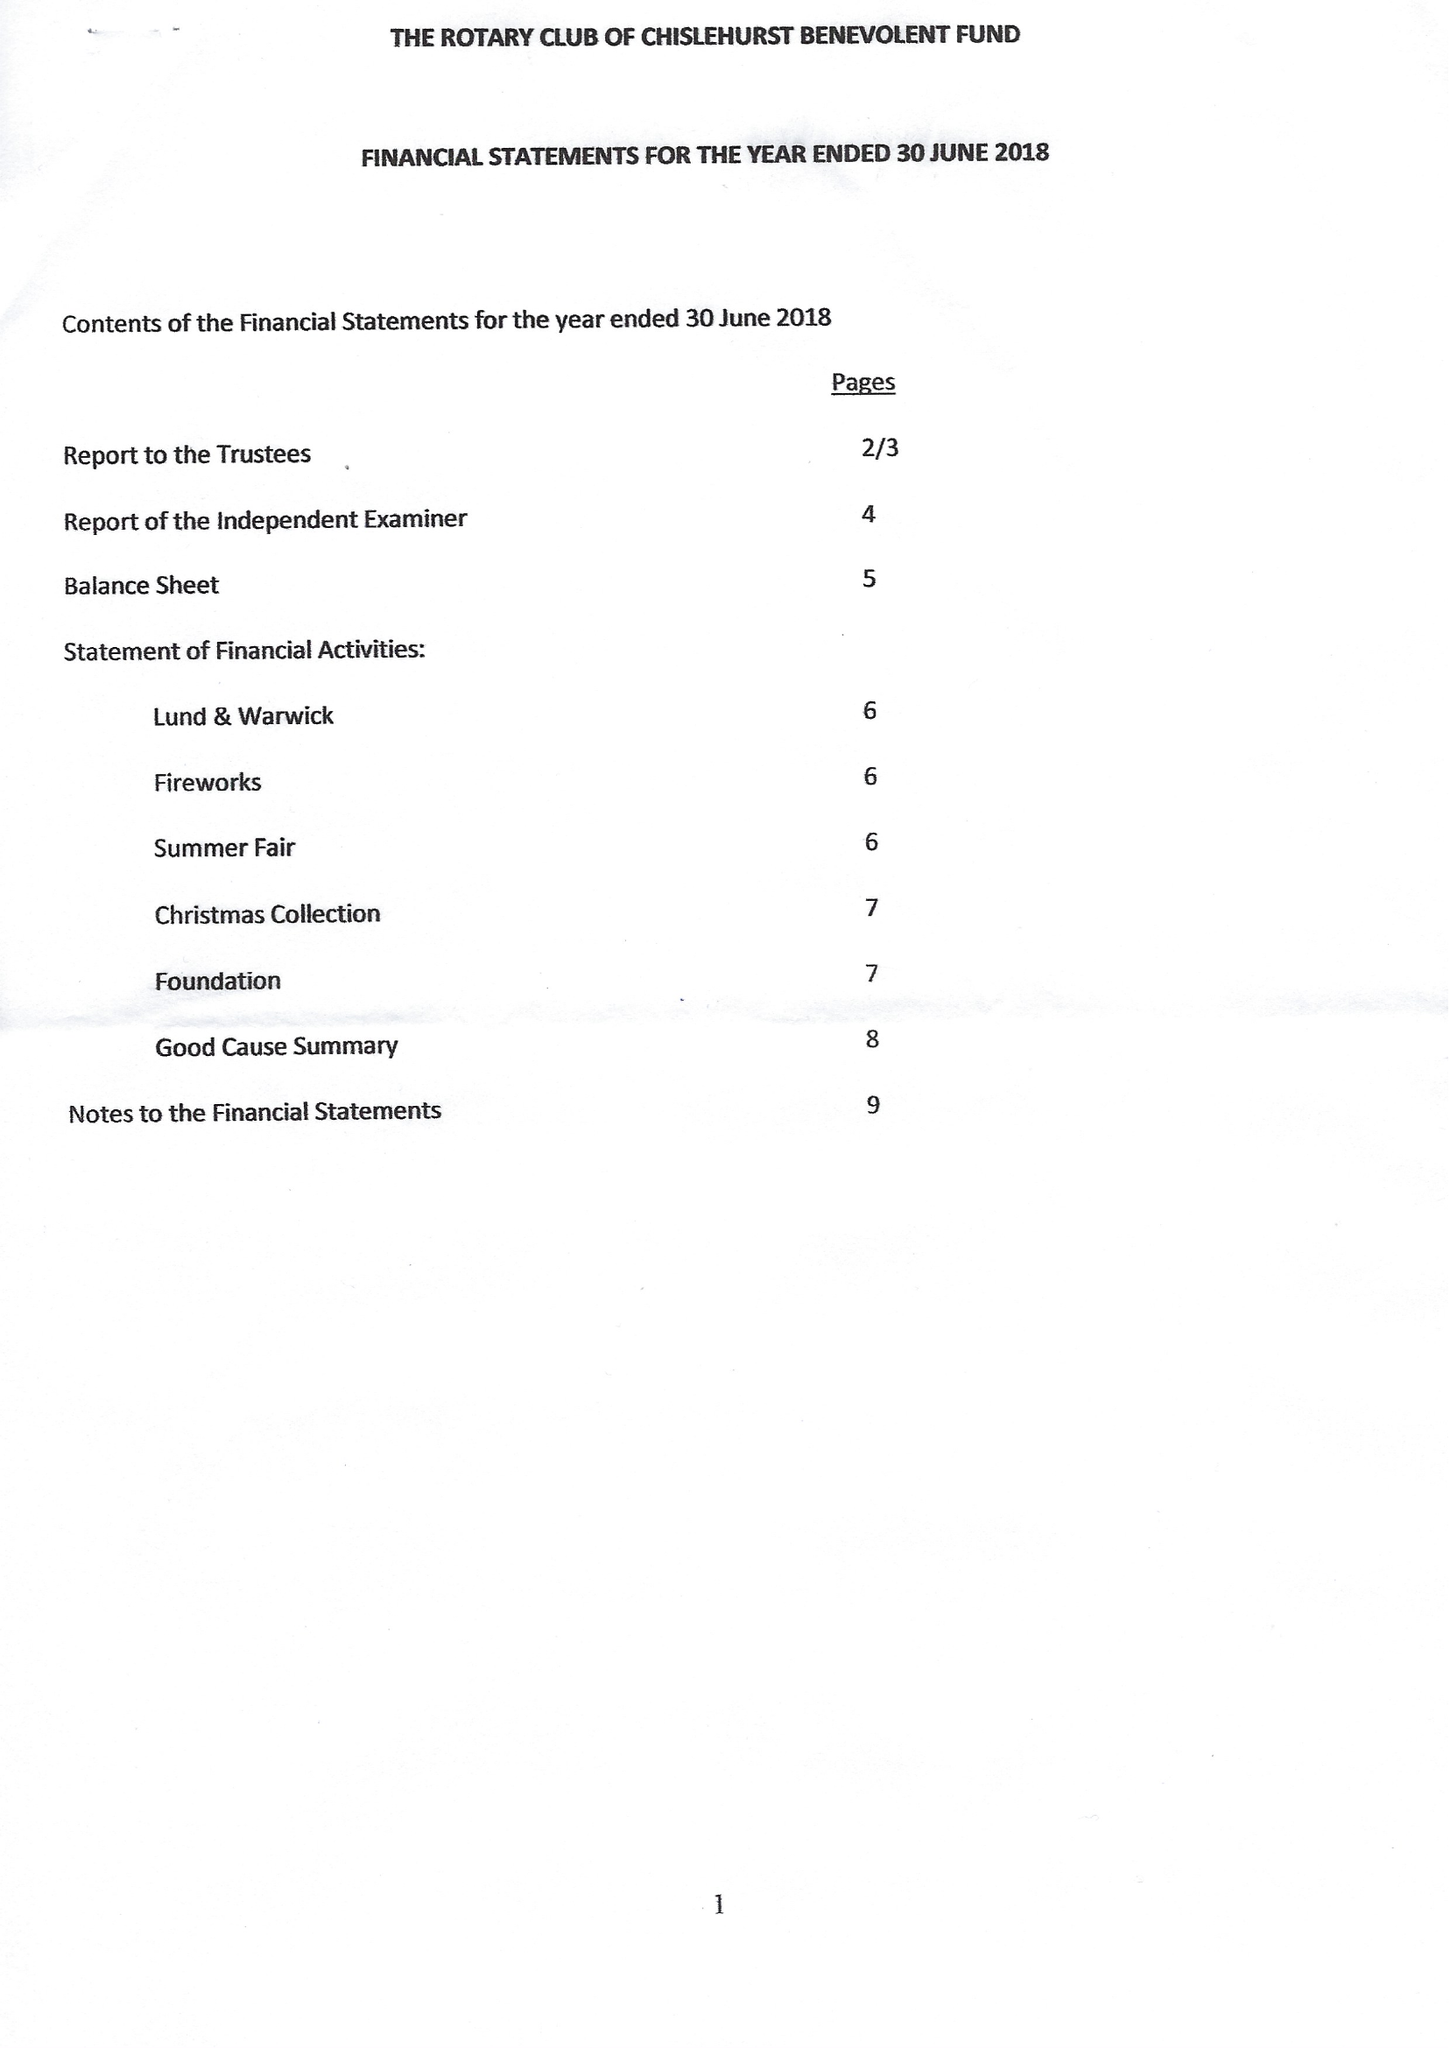What is the value for the charity_number?
Answer the question using a single word or phrase. 257747 